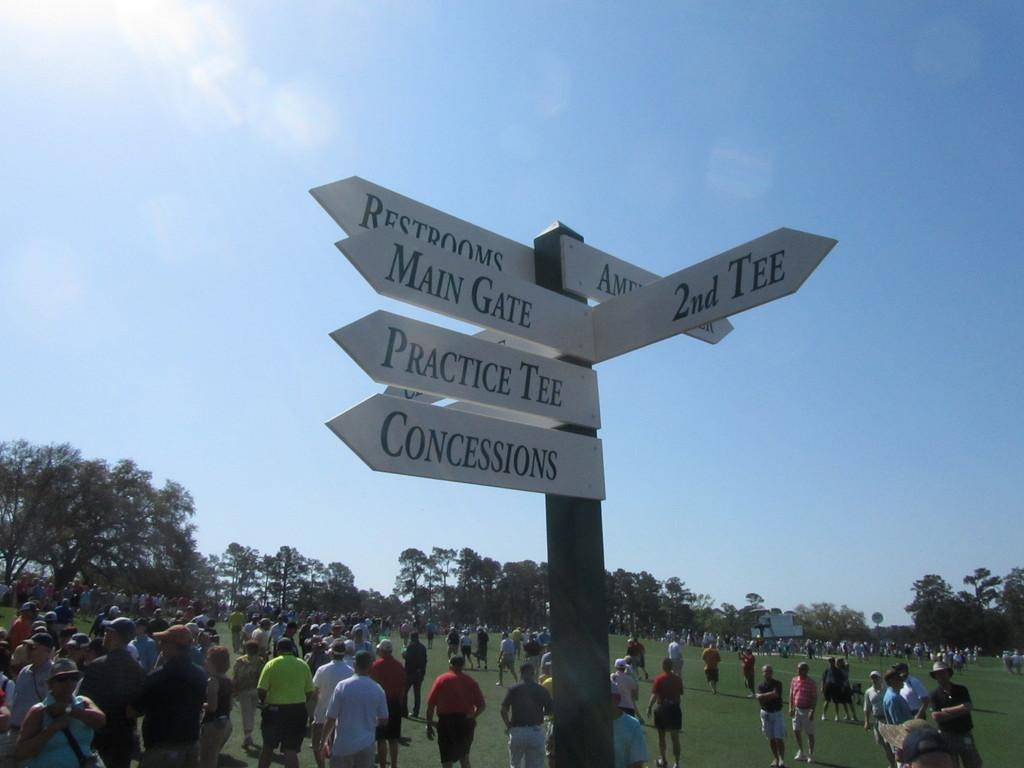What is attached to the pole in the image? There are boards attached to a pole in the image. What can be seen in the background of the image? There are trees with green color in the image. What is the color of the sky? The sky is blue and white in color. Can you describe the people in the image? There is a group of people standing in the image. What type of insect can be seen buzzing around the people in the image? There is no insect present in the image; it only features boards attached to a pole, trees, and a group of people. What is the answer to the question that is not present in the image? The question about an insect is not relevant to the image, as there are no insects present. 